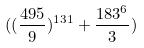<formula> <loc_0><loc_0><loc_500><loc_500>( ( \frac { 4 9 5 } { 9 } ) ^ { 1 3 1 } + \frac { 1 8 3 ^ { 6 } } { 3 } )</formula> 